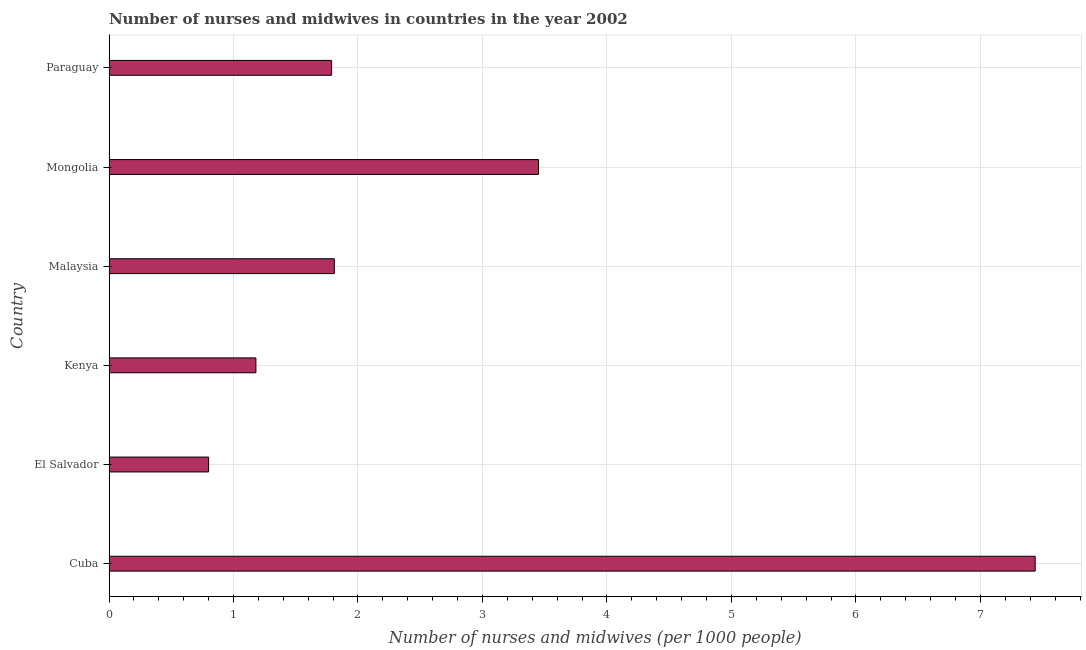Does the graph contain any zero values?
Your response must be concise. No. Does the graph contain grids?
Provide a succinct answer. Yes. What is the title of the graph?
Your answer should be compact. Number of nurses and midwives in countries in the year 2002. What is the label or title of the X-axis?
Offer a very short reply. Number of nurses and midwives (per 1000 people). What is the number of nurses and midwives in Malaysia?
Your answer should be very brief. 1.81. Across all countries, what is the maximum number of nurses and midwives?
Ensure brevity in your answer.  7.44. In which country was the number of nurses and midwives maximum?
Provide a short and direct response. Cuba. In which country was the number of nurses and midwives minimum?
Provide a short and direct response. El Salvador. What is the sum of the number of nurses and midwives?
Provide a succinct answer. 16.47. What is the difference between the number of nurses and midwives in Malaysia and Paraguay?
Keep it short and to the point. 0.02. What is the average number of nurses and midwives per country?
Provide a short and direct response. 2.75. What is the median number of nurses and midwives?
Ensure brevity in your answer.  1.8. What is the ratio of the number of nurses and midwives in Malaysia to that in Paraguay?
Offer a very short reply. 1.01. What is the difference between the highest and the second highest number of nurses and midwives?
Provide a short and direct response. 3.99. Is the sum of the number of nurses and midwives in Malaysia and Mongolia greater than the maximum number of nurses and midwives across all countries?
Your answer should be very brief. No. What is the difference between the highest and the lowest number of nurses and midwives?
Keep it short and to the point. 6.64. How many bars are there?
Your answer should be very brief. 6. How many countries are there in the graph?
Ensure brevity in your answer.  6. What is the difference between two consecutive major ticks on the X-axis?
Ensure brevity in your answer.  1. What is the Number of nurses and midwives (per 1000 people) in Cuba?
Your answer should be compact. 7.44. What is the Number of nurses and midwives (per 1000 people) in El Salvador?
Make the answer very short. 0.8. What is the Number of nurses and midwives (per 1000 people) of Kenya?
Make the answer very short. 1.18. What is the Number of nurses and midwives (per 1000 people) in Malaysia?
Offer a terse response. 1.81. What is the Number of nurses and midwives (per 1000 people) in Mongolia?
Give a very brief answer. 3.45. What is the Number of nurses and midwives (per 1000 people) of Paraguay?
Your answer should be very brief. 1.79. What is the difference between the Number of nurses and midwives (per 1000 people) in Cuba and El Salvador?
Your response must be concise. 6.64. What is the difference between the Number of nurses and midwives (per 1000 people) in Cuba and Kenya?
Offer a very short reply. 6.26. What is the difference between the Number of nurses and midwives (per 1000 people) in Cuba and Malaysia?
Offer a terse response. 5.63. What is the difference between the Number of nurses and midwives (per 1000 people) in Cuba and Mongolia?
Offer a terse response. 3.99. What is the difference between the Number of nurses and midwives (per 1000 people) in Cuba and Paraguay?
Keep it short and to the point. 5.65. What is the difference between the Number of nurses and midwives (per 1000 people) in El Salvador and Kenya?
Provide a short and direct response. -0.38. What is the difference between the Number of nurses and midwives (per 1000 people) in El Salvador and Malaysia?
Provide a short and direct response. -1.01. What is the difference between the Number of nurses and midwives (per 1000 people) in El Salvador and Mongolia?
Keep it short and to the point. -2.65. What is the difference between the Number of nurses and midwives (per 1000 people) in El Salvador and Paraguay?
Provide a succinct answer. -0.99. What is the difference between the Number of nurses and midwives (per 1000 people) in Kenya and Malaysia?
Your answer should be very brief. -0.63. What is the difference between the Number of nurses and midwives (per 1000 people) in Kenya and Mongolia?
Your response must be concise. -2.27. What is the difference between the Number of nurses and midwives (per 1000 people) in Kenya and Paraguay?
Ensure brevity in your answer.  -0.61. What is the difference between the Number of nurses and midwives (per 1000 people) in Malaysia and Mongolia?
Offer a terse response. -1.64. What is the difference between the Number of nurses and midwives (per 1000 people) in Malaysia and Paraguay?
Offer a very short reply. 0.02. What is the difference between the Number of nurses and midwives (per 1000 people) in Mongolia and Paraguay?
Offer a terse response. 1.66. What is the ratio of the Number of nurses and midwives (per 1000 people) in Cuba to that in El Salvador?
Make the answer very short. 9.3. What is the ratio of the Number of nurses and midwives (per 1000 people) in Cuba to that in Kenya?
Provide a succinct answer. 6.3. What is the ratio of the Number of nurses and midwives (per 1000 people) in Cuba to that in Malaysia?
Your response must be concise. 4.11. What is the ratio of the Number of nurses and midwives (per 1000 people) in Cuba to that in Mongolia?
Provide a short and direct response. 2.16. What is the ratio of the Number of nurses and midwives (per 1000 people) in Cuba to that in Paraguay?
Ensure brevity in your answer.  4.16. What is the ratio of the Number of nurses and midwives (per 1000 people) in El Salvador to that in Kenya?
Your answer should be very brief. 0.68. What is the ratio of the Number of nurses and midwives (per 1000 people) in El Salvador to that in Malaysia?
Provide a succinct answer. 0.44. What is the ratio of the Number of nurses and midwives (per 1000 people) in El Salvador to that in Mongolia?
Ensure brevity in your answer.  0.23. What is the ratio of the Number of nurses and midwives (per 1000 people) in El Salvador to that in Paraguay?
Provide a short and direct response. 0.45. What is the ratio of the Number of nurses and midwives (per 1000 people) in Kenya to that in Malaysia?
Your response must be concise. 0.65. What is the ratio of the Number of nurses and midwives (per 1000 people) in Kenya to that in Mongolia?
Offer a terse response. 0.34. What is the ratio of the Number of nurses and midwives (per 1000 people) in Kenya to that in Paraguay?
Ensure brevity in your answer.  0.66. What is the ratio of the Number of nurses and midwives (per 1000 people) in Malaysia to that in Mongolia?
Your answer should be compact. 0.53. What is the ratio of the Number of nurses and midwives (per 1000 people) in Malaysia to that in Paraguay?
Your response must be concise. 1.01. What is the ratio of the Number of nurses and midwives (per 1000 people) in Mongolia to that in Paraguay?
Your response must be concise. 1.93. 